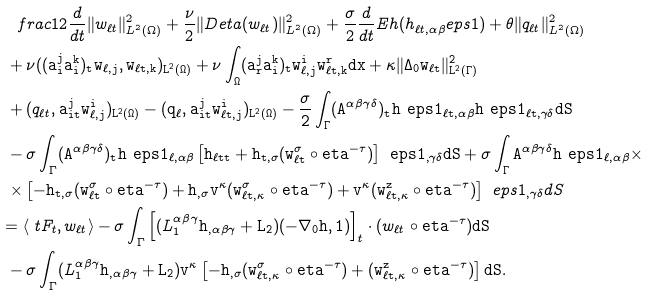<formula> <loc_0><loc_0><loc_500><loc_500>& \quad f r a c { 1 } { 2 } \frac { d } { d t } \| w _ { \ell t } \| ^ { 2 } _ { L ^ { 2 } ( \Omega ) } + \frac { \nu } { 2 } \| D _ { \tt } e t a ( w _ { \ell t } ) \| ^ { 2 } _ { L ^ { 2 } ( \Omega ) } + \frac { \sigma } { 2 } \frac { d } { d t } E _ { \tt } h ( h _ { \ell t , \alpha \beta } ^ { \ } e p s 1 ) + \theta \| q _ { \ell t } \| ^ { 2 } _ { L ^ { 2 } ( \Omega ) } \\ & \ + \nu ( ( \tt a _ { i } ^ { j } \tt a _ { i } ^ { k } ) _ { t } w _ { \ell , j } , w _ { \ell t , k } ) _ { L ^ { 2 } ( \Omega ) } + \nu \int _ { \Omega } ( \tt a _ { r } ^ { j } \tt a ^ { k } _ { i } ) _ { t } w _ { \ell , j } ^ { i } w _ { \ell t , k } ^ { r } d x + \kappa \| \Delta _ { 0 } w _ { \ell t } \| ^ { 2 } _ { L ^ { 2 } ( \Gamma ) } \\ & \ + ( q _ { \ell t } , \tt a _ { i t } ^ { j } w _ { \ell , j } ^ { i } ) _ { L ^ { 2 } ( \Omega ) } - ( q _ { \ell } , \tt a _ { i t } ^ { j } w _ { \ell t , j } ^ { i } ) _ { L ^ { 2 } ( \Omega ) } - \frac { \sigma } { 2 } \int _ { \Gamma } ( \tt A ^ { \alpha \beta \gamma \delta } ) _ { t } h ^ { \ } e p s 1 _ { \ell t , \alpha \beta } h ^ { \ } e p s 1 _ { \ell t , \gamma \delta } d S \\ & \ - \sigma \int _ { \Gamma } ( \tt A ^ { \alpha \beta \gamma \delta } ) _ { t } h ^ { \ } e p s 1 _ { \ell , \alpha \beta } \left [ h _ { \ell t t } + \tt h _ { t , \sigma } ( w _ { \ell t } ^ { \sigma } \circ \tt e t a ^ { - \tau } ) \right ] ^ { \ } e p s 1 _ { , \gamma \delta } d S + \sigma \int _ { \Gamma } \tt A ^ { \alpha \beta \gamma \delta } h ^ { \ } e p s 1 _ { \ell , \alpha \beta } \times \\ & \ \times \left [ - \tt h _ { t , \sigma } ( w _ { \ell t } ^ { \sigma } \circ \tt e t a ^ { - \tau } ) + \tt h _ { , \sigma } \tt v ^ { \kappa } ( w _ { \ell t , \kappa } ^ { \sigma } \circ \tt e t a ^ { - \tau } ) + \tt v ^ { \kappa } ( w _ { \ell t , \kappa } ^ { z } \circ \tt e t a ^ { - \tau } ) \right ] ^ { \ } e p s 1 _ { , \gamma \delta } d S \\ & = \langle \ t F _ { t } , w _ { \ell t } \rangle - \sigma \int _ { \Gamma } \left [ ( L _ { 1 } ^ { \alpha \beta \gamma } \tt h _ { , \alpha \beta \gamma } + L _ { 2 } ) ( - \nabla _ { 0 } \tt h , 1 ) \right ] _ { t } \cdot ( w _ { \ell t } \circ \tt e t a ^ { - \tau } ) d S \\ & \ - \sigma \int _ { \Gamma } ( L _ { 1 } ^ { \alpha \beta \gamma } \tt h _ { , \alpha \beta \gamma } + L _ { 2 } ) \tt v ^ { \kappa } \left [ - \tt h _ { , \sigma } ( w ^ { \sigma } _ { \ell t , \kappa } \circ \tt e t a ^ { - \tau } ) + ( w ^ { z } _ { \ell t , \kappa } \circ \tt e t a ^ { - \tau } ) \right ] d S .</formula> 